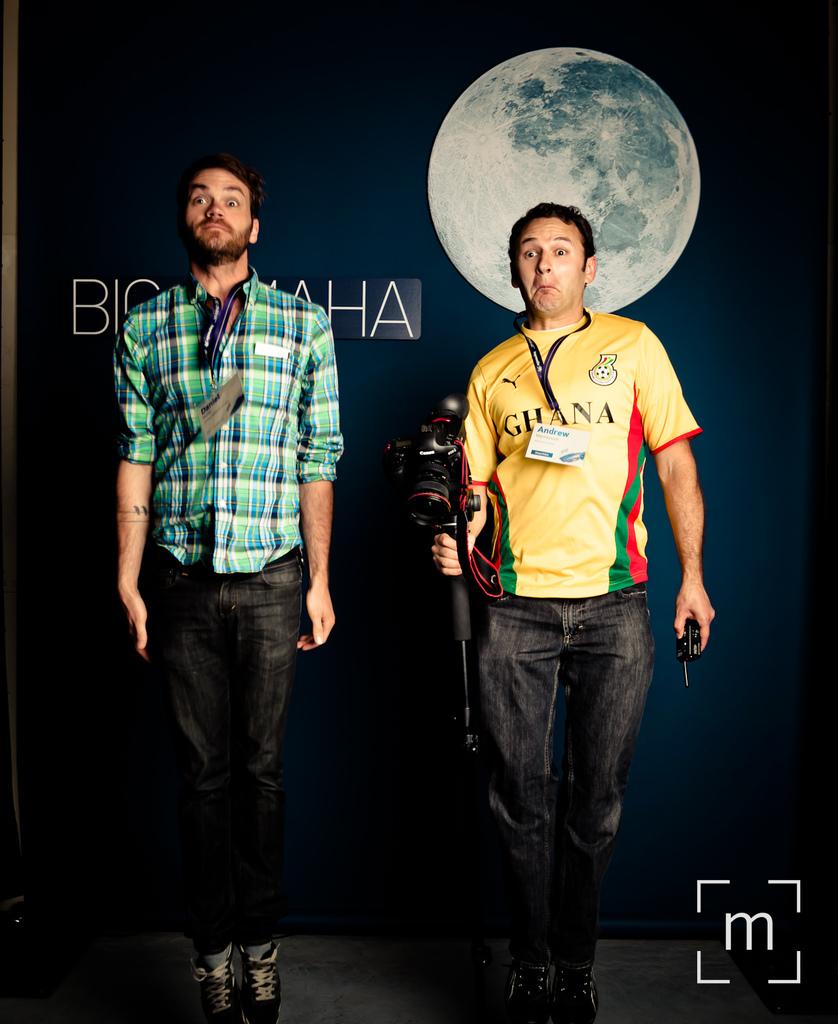What letter is in the bottom right corner?
Provide a succinct answer. M. 